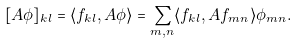<formula> <loc_0><loc_0><loc_500><loc_500>[ A \phi ] _ { k l } = \langle f _ { k l } , A \phi \rangle = \sum _ { m , n } \langle f _ { k l } , A f _ { m n } \rangle \phi _ { m n } .</formula> 